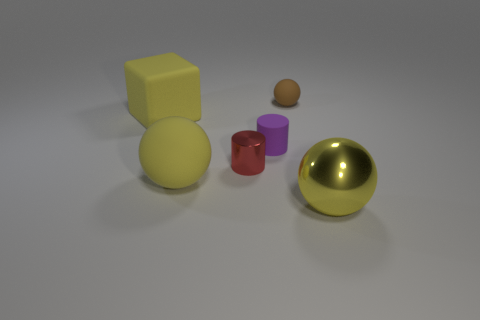Do the metallic thing that is right of the brown thing and the rubber sphere that is to the left of the red thing have the same color?
Ensure brevity in your answer.  Yes. There is a sphere that is behind the red shiny cylinder; what number of small things are in front of it?
Make the answer very short. 2. Are any small gray matte blocks visible?
Offer a terse response. No. What number of other things are there of the same color as the big metallic sphere?
Provide a short and direct response. 2. Is the number of small brown blocks less than the number of yellow blocks?
Give a very brief answer. Yes. There is a shiny thing to the right of the matte sphere behind the small metallic cylinder; what shape is it?
Your answer should be compact. Sphere. There is a purple cylinder; are there any metallic things right of it?
Your response must be concise. Yes. What color is the other matte thing that is the same size as the purple rubber object?
Keep it short and to the point. Brown. How many blue blocks are made of the same material as the brown ball?
Ensure brevity in your answer.  0. How many other objects are there of the same size as the brown object?
Give a very brief answer. 2. 